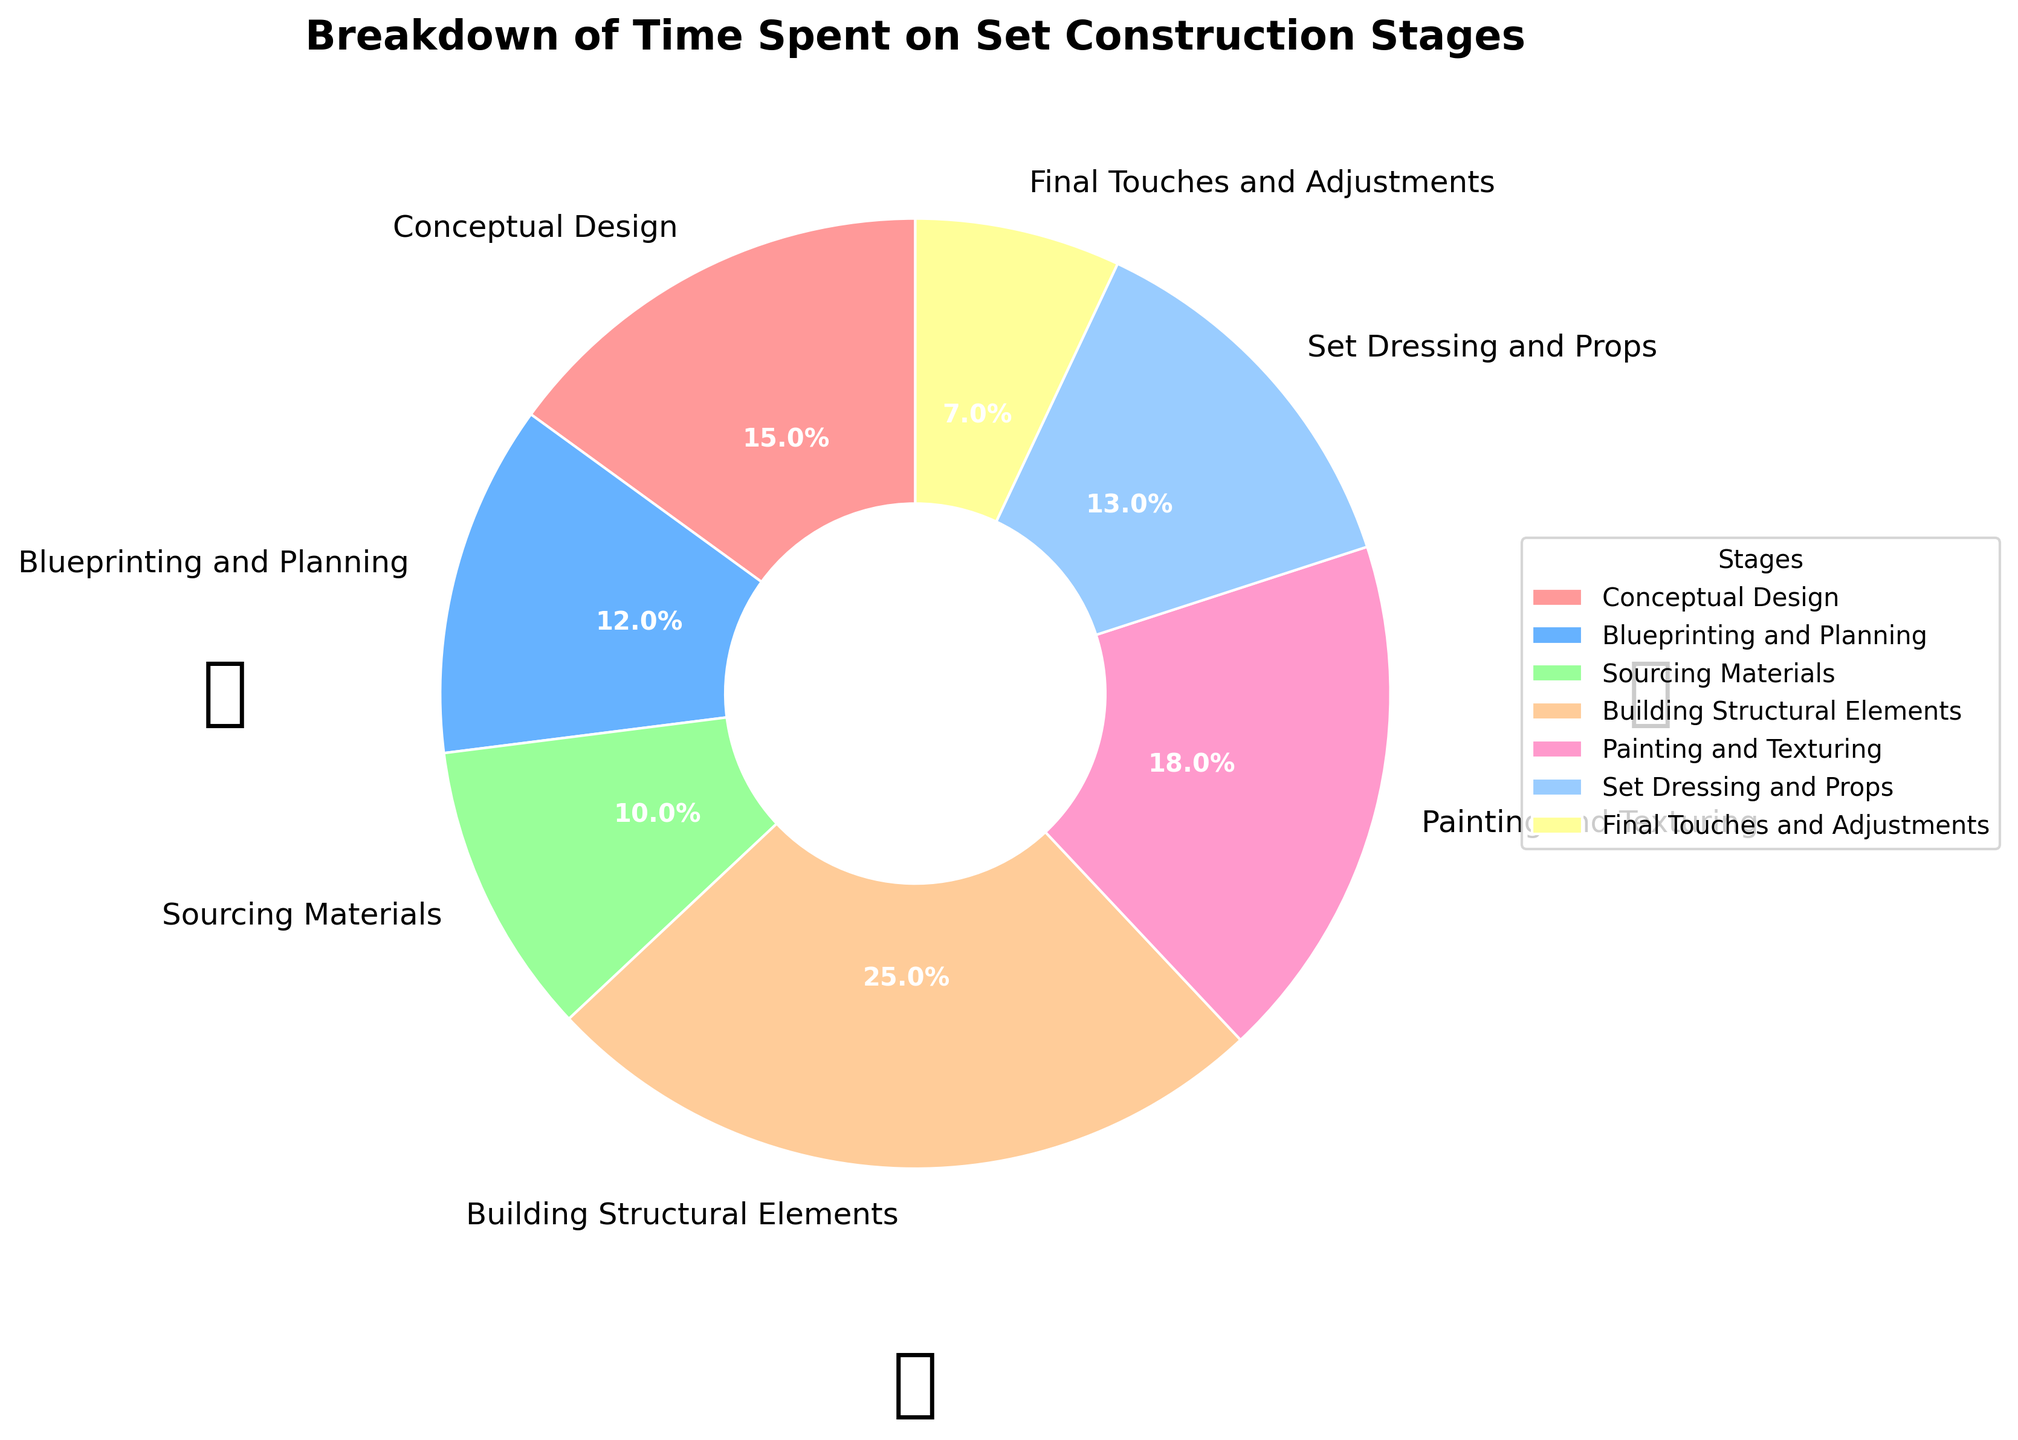What percentage of time is spent on conceptual design? The pie chart has Conceptual Design labeled with a percentage.
Answer: 15% Which stage takes the most amount of time? The pie chart shows the percentages of each stage. The largest percentage is for Building Structural Elements.
Answer: Building Structural Elements How much more time is spent on painting and texturing compared to sourcing materials? Painting and Texturing: 18%, Sourcing Materials: 10%. The difference is 18% - 10%.
Answer: 8% What is the combined percentage of time spent on set dressing and props, and final touches and adjustments? Add the percentages for Set Dressing and Props (13%) and Final Touches and Adjustments (7%). 13% + 7%
Answer: 20% Which stage occupies the smallest visual slice in the pie chart? The smallest percentage slice in the pie chart represents Final Touches and Adjustments.
Answer: Final Touches and Adjustments Is more time spent on blueprinting and planning or on sourcing materials? Blueprinting and Planning: 12%, Sourcing Materials: 10%. 12% is greater than 10%.
Answer: Blueprinting and Planning How does the time spent on building structural elements compare to painting and texturing? Building Structural Elements: 25%, Painting and Texturing: 18%. 25% is greater than 18%.
Answer: More time is spent on Building Structural Elements What’s the difference in time spent between the stage that takes the second most time and the stage that takes the least amount of time? The second largest slice is Painting and Texturing (18%), and the smallest is Final Touches and Adjustments (7%). The difference is 18% - 7%.
Answer: 11% How many stages have a percentage greater than 15%? The stages with percentages greater than 15% are Conceptual Design (15%), Building Structural Elements (25%), and Painting and Texturing (18%).
Answer: 3 